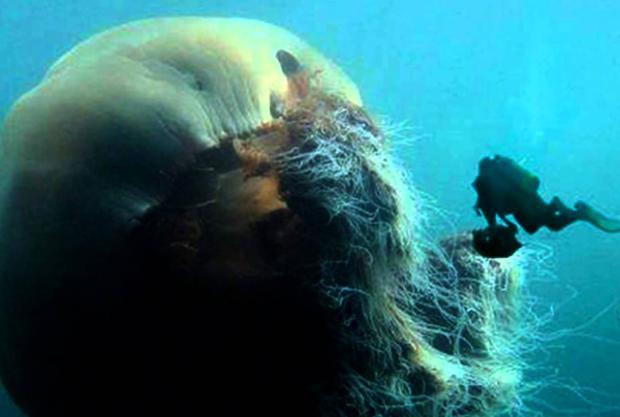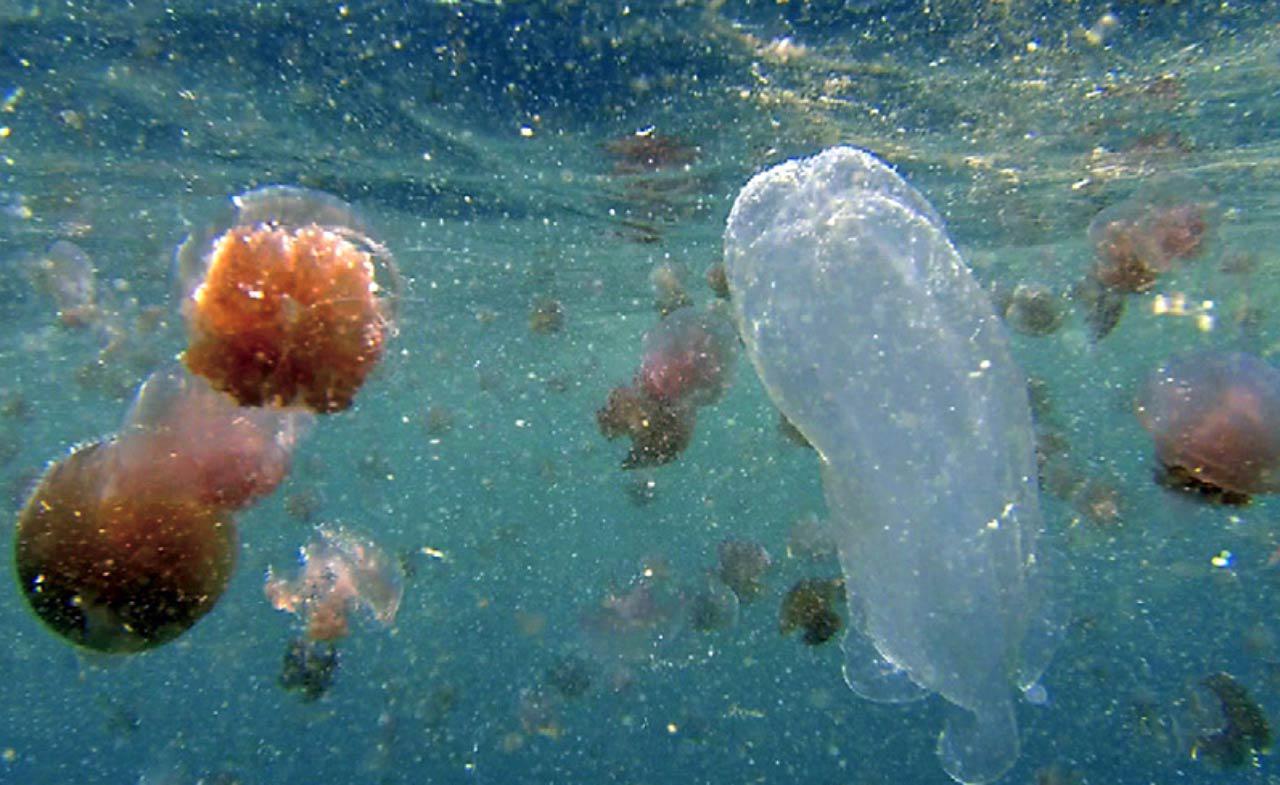The first image is the image on the left, the second image is the image on the right. Examine the images to the left and right. Is the description "Each image includes a person wearing a scuba-type wetsuit." accurate? Answer yes or no. No. The first image is the image on the left, the second image is the image on the right. Examine the images to the left and right. Is the description "There is at least one person without an airtank." accurate? Answer yes or no. No. 